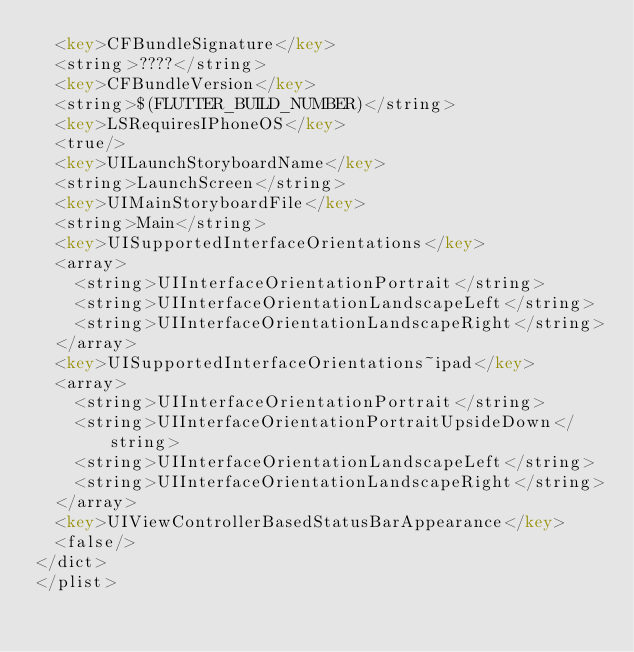Convert code to text. <code><loc_0><loc_0><loc_500><loc_500><_XML_>	<key>CFBundleSignature</key>
	<string>????</string>
	<key>CFBundleVersion</key>
	<string>$(FLUTTER_BUILD_NUMBER)</string>
	<key>LSRequiresIPhoneOS</key>
	<true/>
	<key>UILaunchStoryboardName</key>
	<string>LaunchScreen</string>
	<key>UIMainStoryboardFile</key>
	<string>Main</string>
	<key>UISupportedInterfaceOrientations</key>
	<array>
		<string>UIInterfaceOrientationPortrait</string>
		<string>UIInterfaceOrientationLandscapeLeft</string>
		<string>UIInterfaceOrientationLandscapeRight</string>
	</array>
	<key>UISupportedInterfaceOrientations~ipad</key>
	<array>
		<string>UIInterfaceOrientationPortrait</string>
		<string>UIInterfaceOrientationPortraitUpsideDown</string>
		<string>UIInterfaceOrientationLandscapeLeft</string>
		<string>UIInterfaceOrientationLandscapeRight</string>
	</array>
	<key>UIViewControllerBasedStatusBarAppearance</key>
	<false/>
</dict>
</plist>
</code> 